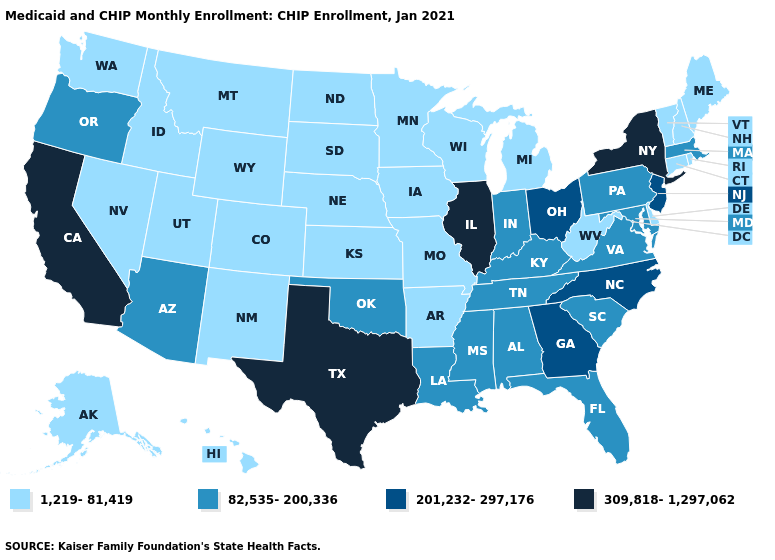What is the value of Washington?
Be succinct. 1,219-81,419. Name the states that have a value in the range 1,219-81,419?
Answer briefly. Alaska, Arkansas, Colorado, Connecticut, Delaware, Hawaii, Idaho, Iowa, Kansas, Maine, Michigan, Minnesota, Missouri, Montana, Nebraska, Nevada, New Hampshire, New Mexico, North Dakota, Rhode Island, South Dakota, Utah, Vermont, Washington, West Virginia, Wisconsin, Wyoming. What is the value of New Jersey?
Give a very brief answer. 201,232-297,176. Is the legend a continuous bar?
Give a very brief answer. No. Which states have the lowest value in the MidWest?
Keep it brief. Iowa, Kansas, Michigan, Minnesota, Missouri, Nebraska, North Dakota, South Dakota, Wisconsin. What is the value of New Hampshire?
Quick response, please. 1,219-81,419. Which states have the highest value in the USA?
Quick response, please. California, Illinois, New York, Texas. Does Rhode Island have a higher value than South Carolina?
Concise answer only. No. Name the states that have a value in the range 82,535-200,336?
Be succinct. Alabama, Arizona, Florida, Indiana, Kentucky, Louisiana, Maryland, Massachusetts, Mississippi, Oklahoma, Oregon, Pennsylvania, South Carolina, Tennessee, Virginia. Does California have the highest value in the USA?
Answer briefly. Yes. What is the lowest value in states that border North Dakota?
Quick response, please. 1,219-81,419. Name the states that have a value in the range 201,232-297,176?
Write a very short answer. Georgia, New Jersey, North Carolina, Ohio. Name the states that have a value in the range 82,535-200,336?
Concise answer only. Alabama, Arizona, Florida, Indiana, Kentucky, Louisiana, Maryland, Massachusetts, Mississippi, Oklahoma, Oregon, Pennsylvania, South Carolina, Tennessee, Virginia. Among the states that border Indiana , which have the lowest value?
Quick response, please. Michigan. Does the first symbol in the legend represent the smallest category?
Write a very short answer. Yes. 